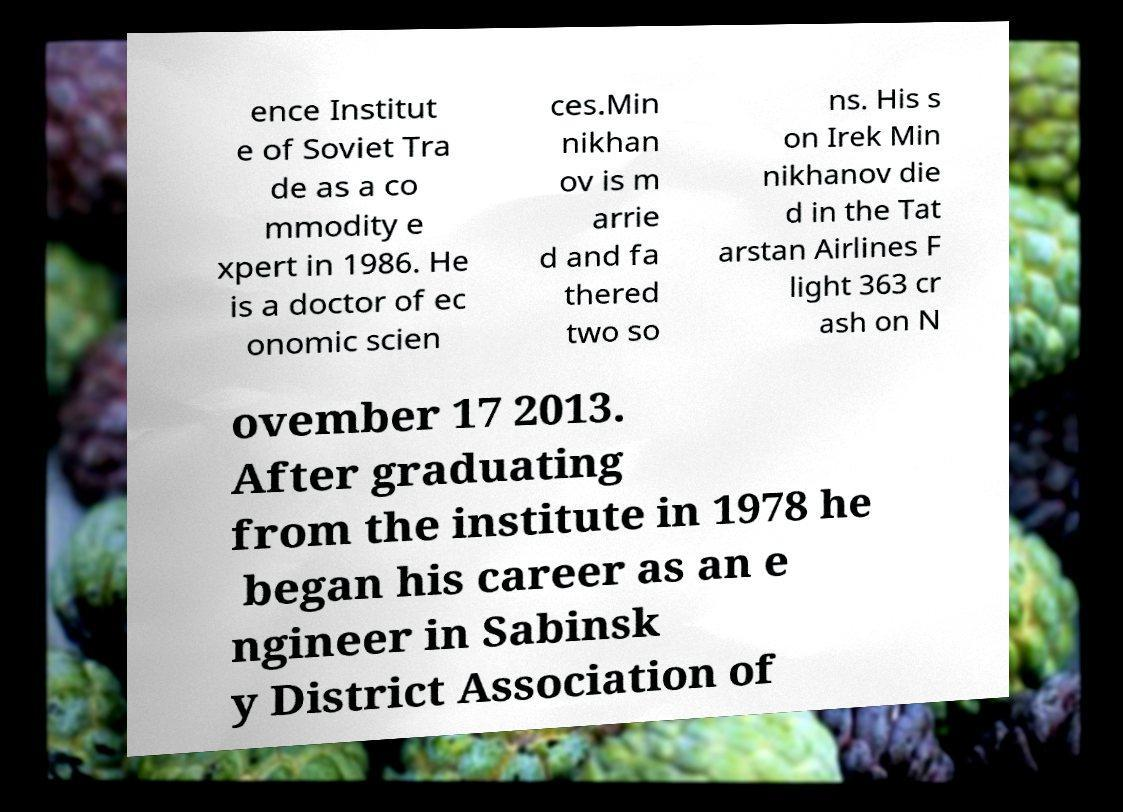There's text embedded in this image that I need extracted. Can you transcribe it verbatim? ence Institut e of Soviet Tra de as a co mmodity e xpert in 1986. He is a doctor of ec onomic scien ces.Min nikhan ov is m arrie d and fa thered two so ns. His s on Irek Min nikhanov die d in the Tat arstan Airlines F light 363 cr ash on N ovember 17 2013. After graduating from the institute in 1978 he began his career as an e ngineer in Sabinsk y District Association of 